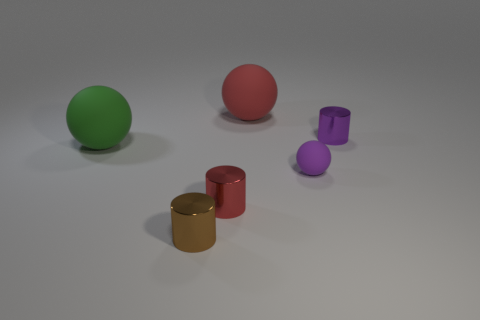The other object that is the same color as the tiny matte object is what size?
Your response must be concise. Small. What number of other tiny matte spheres are the same color as the small rubber ball?
Ensure brevity in your answer.  0. There is a big matte object in front of the big red ball; does it have the same color as the small ball?
Provide a short and direct response. No. There is a rubber object that is behind the big sphere in front of the tiny cylinder right of the red metal cylinder; what color is it?
Your answer should be very brief. Red. Is the material of the tiny purple ball the same as the small brown cylinder?
Provide a short and direct response. No. Is there a tiny purple thing that is behind the large object that is to the right of the brown metallic cylinder that is in front of the red cylinder?
Your response must be concise. No. Is the number of green rubber things less than the number of metal objects?
Your answer should be very brief. Yes. Is the material of the sphere behind the green rubber thing the same as the cylinder that is behind the green object?
Your answer should be compact. No. Is the number of big green spheres in front of the small purple ball less than the number of large red balls?
Your answer should be very brief. Yes. There is a ball behind the green rubber sphere; how many red objects are in front of it?
Keep it short and to the point. 1. 